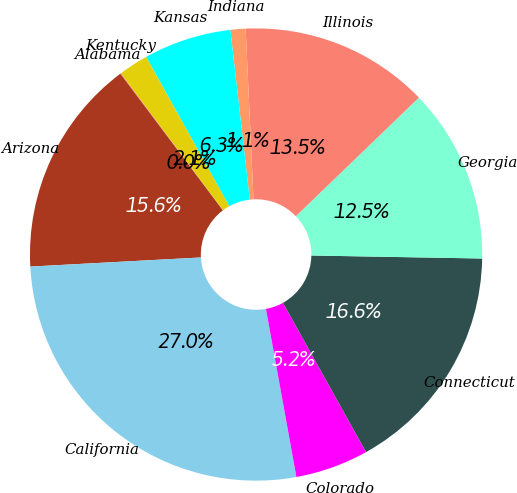Convert chart. <chart><loc_0><loc_0><loc_500><loc_500><pie_chart><fcel>Alabama<fcel>Arizona<fcel>California<fcel>Colorado<fcel>Connecticut<fcel>Georgia<fcel>Illinois<fcel>Indiana<fcel>Kansas<fcel>Kentucky<nl><fcel>0.05%<fcel>15.6%<fcel>27.01%<fcel>5.23%<fcel>16.64%<fcel>12.49%<fcel>13.53%<fcel>1.08%<fcel>6.27%<fcel>2.12%<nl></chart> 